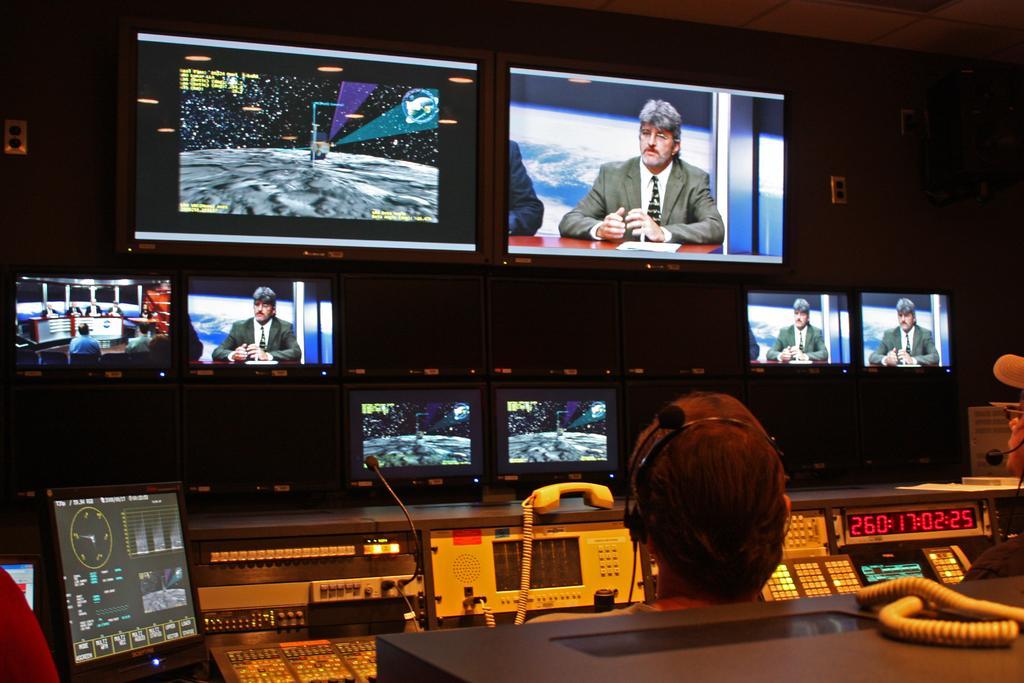How would you summarize this image in a sentence or two? At the bottom of the picture, the man is sitting on the chair. Behind him, we see a box in black color. In front of him, we see a telephone and electronic equipment. In front of him, we see monitor screens which is displaying the man who is sitting on the chair. In front of him, we see a table on which paper is placed. In the background, it is black in color. This picture is clicked in the broadcast control room. 